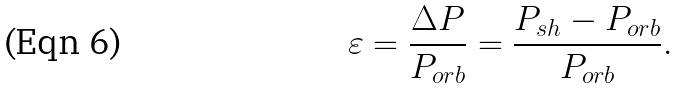Convert formula to latex. <formula><loc_0><loc_0><loc_500><loc_500>\varepsilon = \frac { \Delta P } { P _ { o r b } } = \frac { P _ { s h } - P _ { o r b } } { P _ { o r b } } .</formula> 